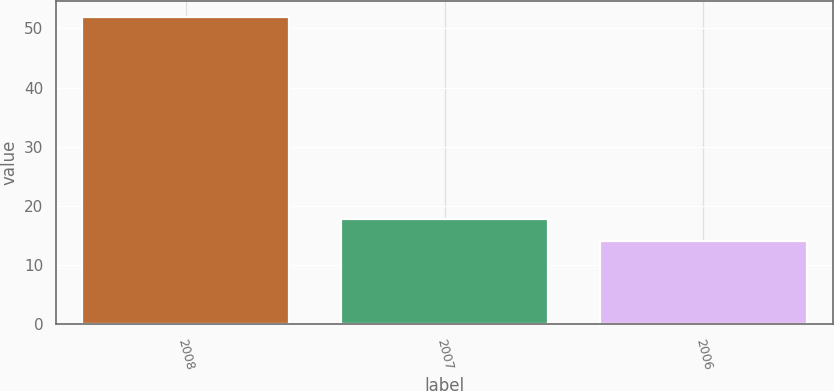Convert chart. <chart><loc_0><loc_0><loc_500><loc_500><bar_chart><fcel>2008<fcel>2007<fcel>2006<nl><fcel>52<fcel>17.8<fcel>14<nl></chart> 